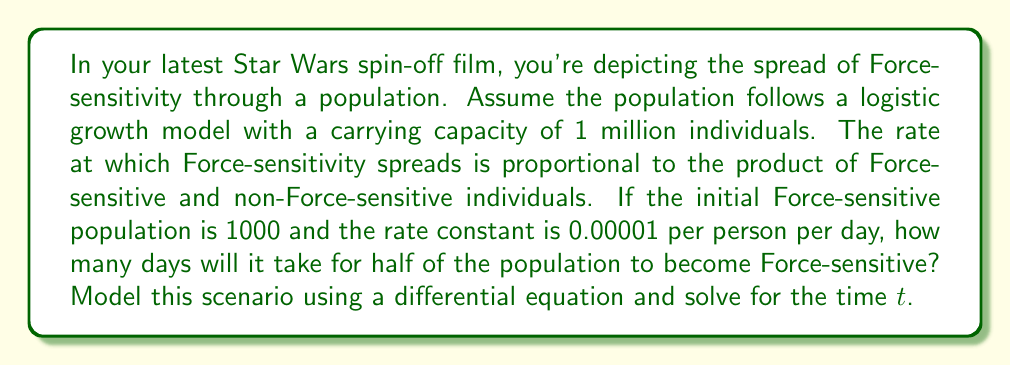Can you answer this question? Let's approach this step-by-step:

1) Let $F(t)$ be the number of Force-sensitive individuals at time $t$. The logistic differential equation for this scenario is:

   $$\frac{dF}{dt} = kF(N-F)$$

   where $k$ is the rate constant, and $N$ is the carrying capacity.

2) Given information:
   - $k = 0.00001$ per person per day
   - $N = 1,000,000$ (carrying capacity)
   - $F(0) = 1000$ (initial Force-sensitive population)

3) We want to find $t$ when $F(t) = 500,000$ (half of the population).

4) The solution to the logistic differential equation is:

   $$F(t) = \frac{N}{1 + (\frac{N}{F_0} - 1)e^{-kNt}}$$

   where $F_0$ is the initial population.

5) Substituting our values:

   $$500,000 = \frac{1,000,000}{1 + (\frac{1,000,000}{1000} - 1)e^{-0.00001 \cdot 1,000,000 \cdot t}}$$

6) Simplifying:

   $$\frac{1}{2} = \frac{1}{1 + 999e^{-10t}}$$

7) Solving for $t$:

   $$1 + 999e^{-10t} = 2$$
   $$999e^{-10t} = 1$$
   $$e^{-10t} = \frac{1}{999}$$
   $$-10t = \ln(\frac{1}{999})$$
   $$t = -\frac{1}{10}\ln(\frac{1}{999}) = \frac{1}{10}\ln(999)$$

8) Calculating the final value:

   $$t \approx 0.6908 \cdot 10 \approx 6.908$$
Answer: It will take approximately 6.908 days for half of the population to become Force-sensitive. 